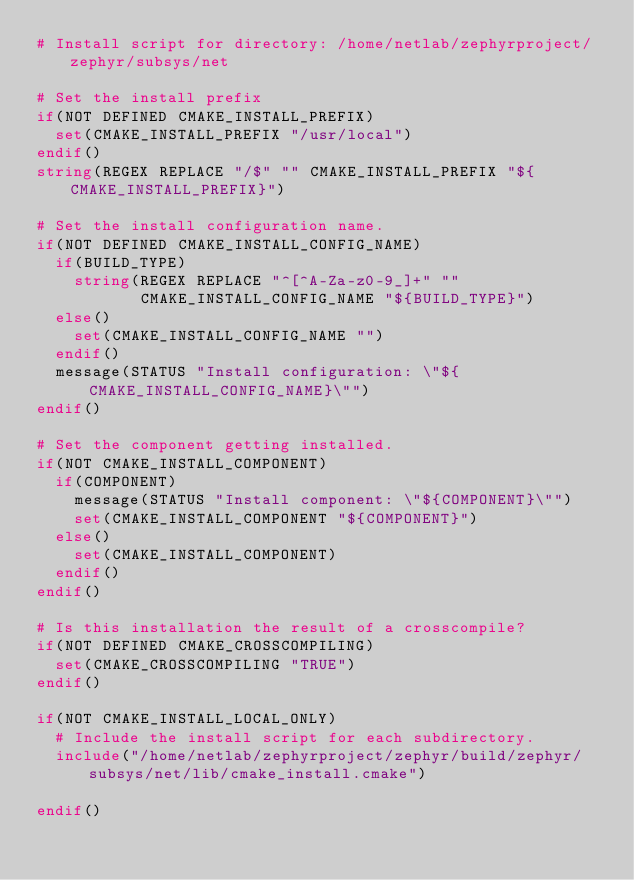<code> <loc_0><loc_0><loc_500><loc_500><_CMake_># Install script for directory: /home/netlab/zephyrproject/zephyr/subsys/net

# Set the install prefix
if(NOT DEFINED CMAKE_INSTALL_PREFIX)
  set(CMAKE_INSTALL_PREFIX "/usr/local")
endif()
string(REGEX REPLACE "/$" "" CMAKE_INSTALL_PREFIX "${CMAKE_INSTALL_PREFIX}")

# Set the install configuration name.
if(NOT DEFINED CMAKE_INSTALL_CONFIG_NAME)
  if(BUILD_TYPE)
    string(REGEX REPLACE "^[^A-Za-z0-9_]+" ""
           CMAKE_INSTALL_CONFIG_NAME "${BUILD_TYPE}")
  else()
    set(CMAKE_INSTALL_CONFIG_NAME "")
  endif()
  message(STATUS "Install configuration: \"${CMAKE_INSTALL_CONFIG_NAME}\"")
endif()

# Set the component getting installed.
if(NOT CMAKE_INSTALL_COMPONENT)
  if(COMPONENT)
    message(STATUS "Install component: \"${COMPONENT}\"")
    set(CMAKE_INSTALL_COMPONENT "${COMPONENT}")
  else()
    set(CMAKE_INSTALL_COMPONENT)
  endif()
endif()

# Is this installation the result of a crosscompile?
if(NOT DEFINED CMAKE_CROSSCOMPILING)
  set(CMAKE_CROSSCOMPILING "TRUE")
endif()

if(NOT CMAKE_INSTALL_LOCAL_ONLY)
  # Include the install script for each subdirectory.
  include("/home/netlab/zephyrproject/zephyr/build/zephyr/subsys/net/lib/cmake_install.cmake")

endif()

</code> 